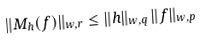<formula> <loc_0><loc_0><loc_500><loc_500>\| M _ { h } ( f ) \| _ { w , r } \leq \| h \| _ { w , q } \, \| f \| _ { w , p }</formula> 